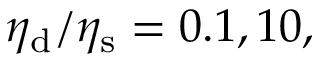<formula> <loc_0><loc_0><loc_500><loc_500>\eta _ { d } / \eta _ { s } = 0 . 1 , 1 0 ,</formula> 